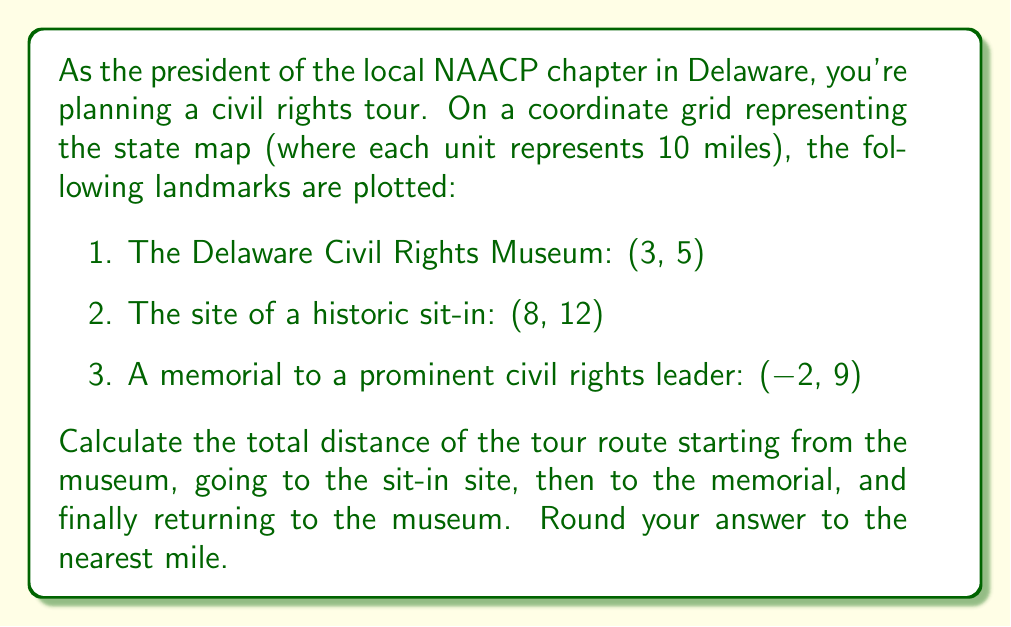Show me your answer to this math problem. To solve this problem, we need to calculate the distance between each pair of points and sum them up. We'll use the distance formula derived from the Pythagorean theorem:

$$d = \sqrt{(x_2-x_1)^2 + (y_2-y_1)^2}$$

Let's calculate each leg of the journey:

1. From museum to sit-in site:
   $d_1 = \sqrt{(8-3)^2 + (12-5)^2} = \sqrt{5^2 + 7^2} = \sqrt{25 + 49} = \sqrt{74} \approx 8.60$ units

2. From sit-in site to memorial:
   $d_2 = \sqrt{(-2-8)^2 + (9-12)^2} = \sqrt{(-10)^2 + (-3)^2} = \sqrt{100 + 9} = \sqrt{109} \approx 10.44$ units

3. From memorial back to museum:
   $d_3 = \sqrt{(3-(-2))^2 + (5-9)^2} = \sqrt{5^2 + (-4)^2} = \sqrt{25 + 16} = \sqrt{41} \approx 6.40$ units

Total distance in units:
$d_{total} = d_1 + d_2 + d_3 \approx 8.60 + 10.44 + 6.40 = 25.44$ units

Since each unit represents 10 miles:
$25.44 \times 10 = 254.4$ miles

Rounding to the nearest mile: 254 miles
Answer: 254 miles 